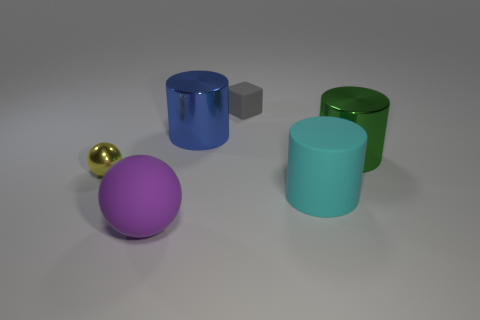Add 3 large cyan rubber spheres. How many objects exist? 9 Subtract all spheres. How many objects are left? 4 Subtract all yellow things. Subtract all big green cylinders. How many objects are left? 4 Add 6 big blue metallic cylinders. How many big blue metallic cylinders are left? 7 Add 3 tiny metallic balls. How many tiny metallic balls exist? 4 Subtract 0 blue spheres. How many objects are left? 6 